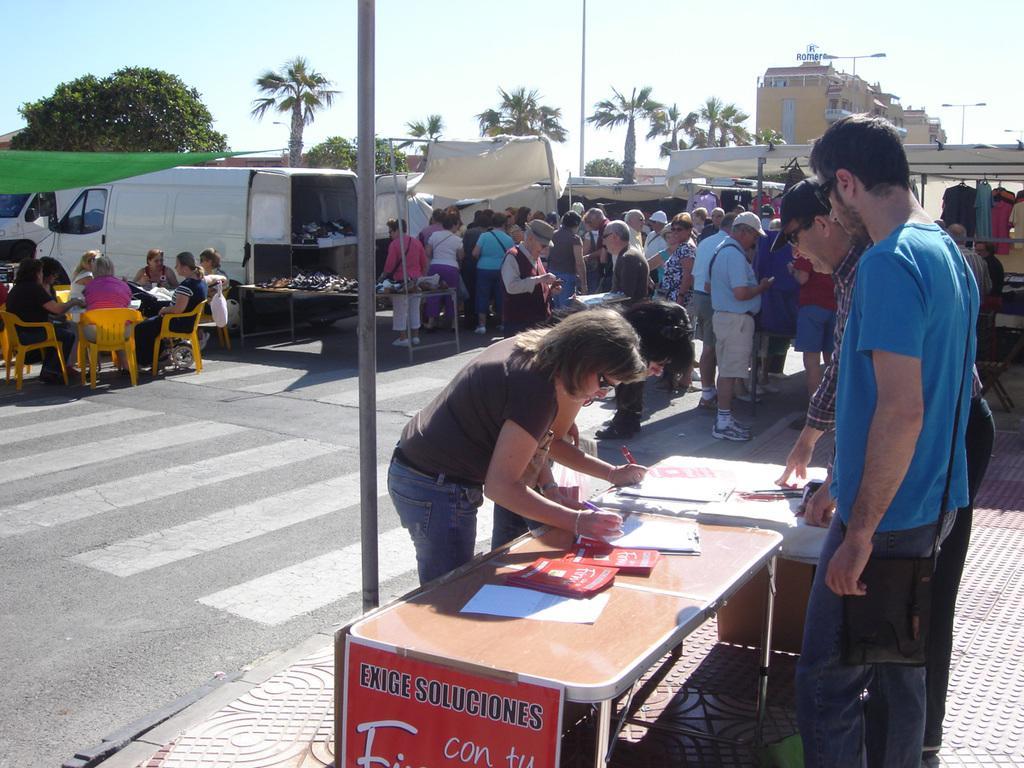In one or two sentences, can you explain what this image depicts? In this image we can see people are standing near the table and writing while holding a pens in their hands. In the background we can see this people sitting on chairs and this people are standing. We can see truck, trees, tents and buildings. 